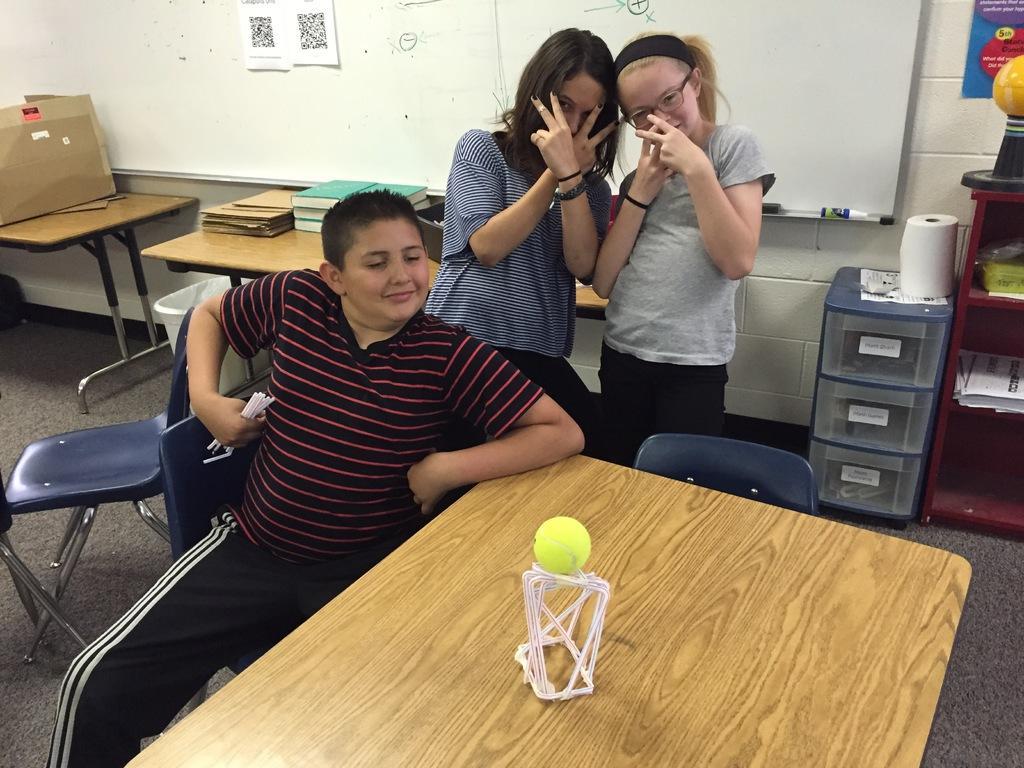Can you describe this image briefly? This is the picture inside the room. There are three people in the image, one is sitting and two are standing behind the chairs. At the left there is a box on the table, at the right there are papers on the table, at the back there is a board. There are books, ball on the table. 